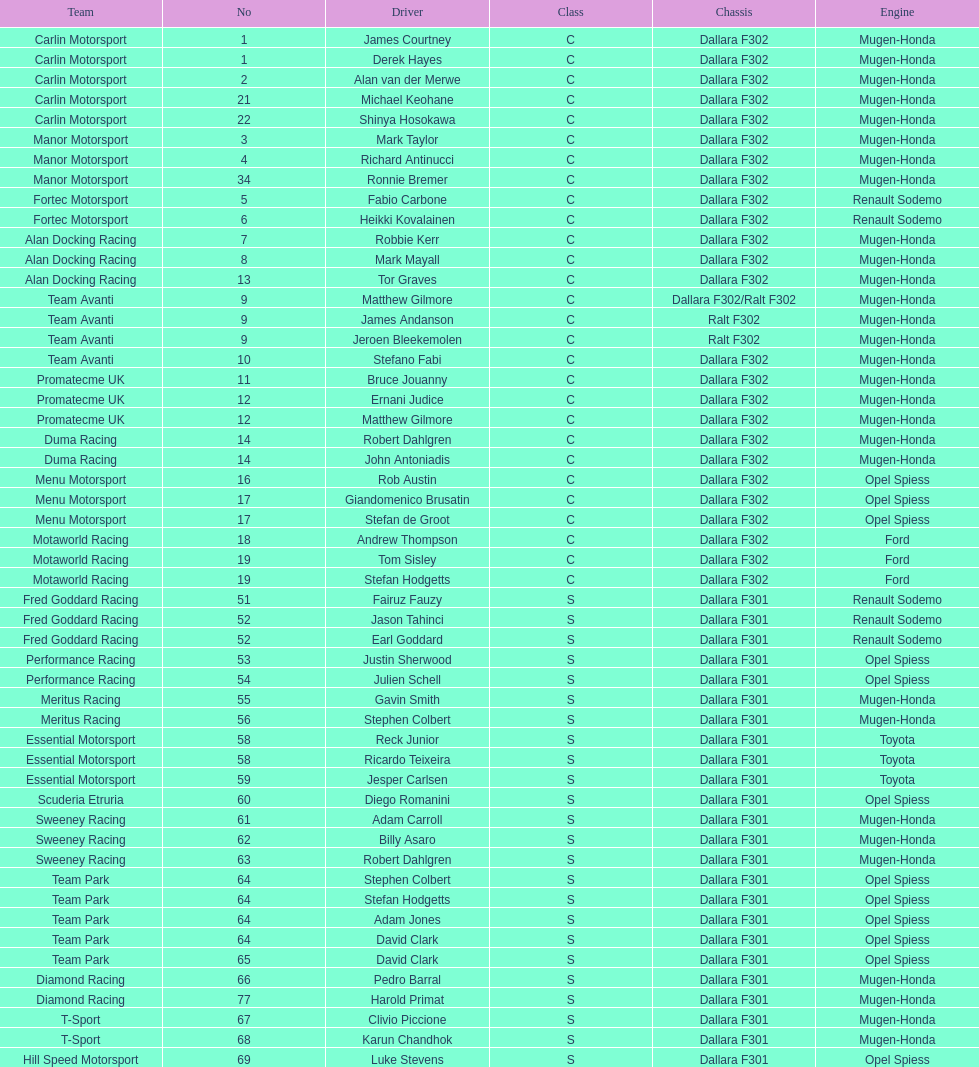What is the total number of class c (championship) teams? 21. 